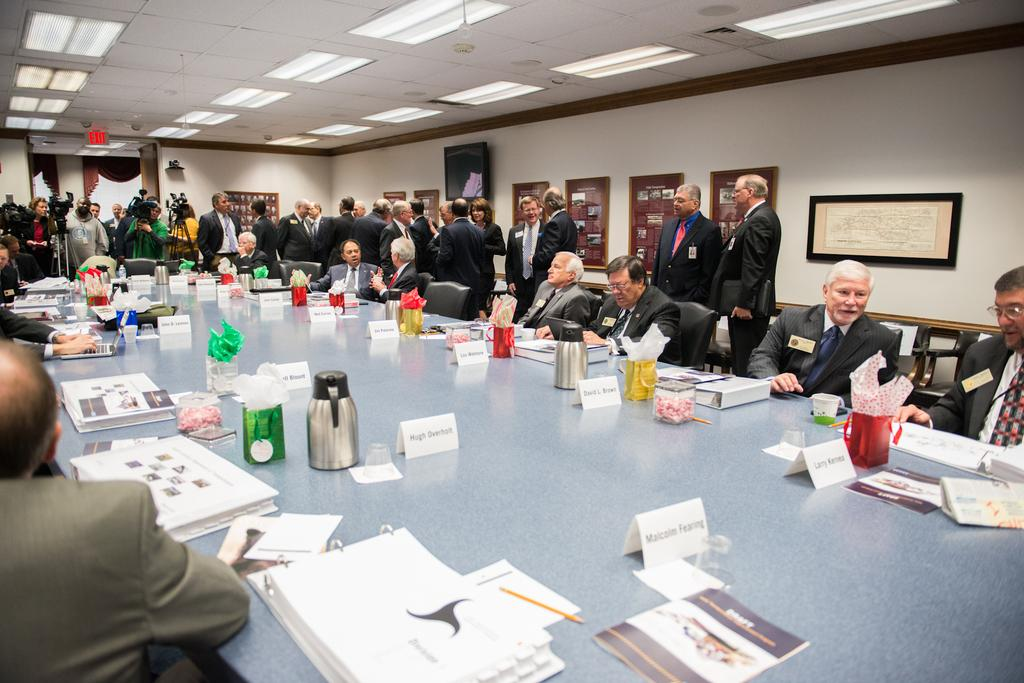How many people are in the image? There are people in the image, but the exact number is not specified. What are some of the people doing in the image? Some of the people are sitting, and some are standing. What is present on the table in the image? A water bag is kept on the table. What type of pencil is being used by the person in the image? There is no mention of a pencil in the image, so it cannot be determined if someone is using one. 